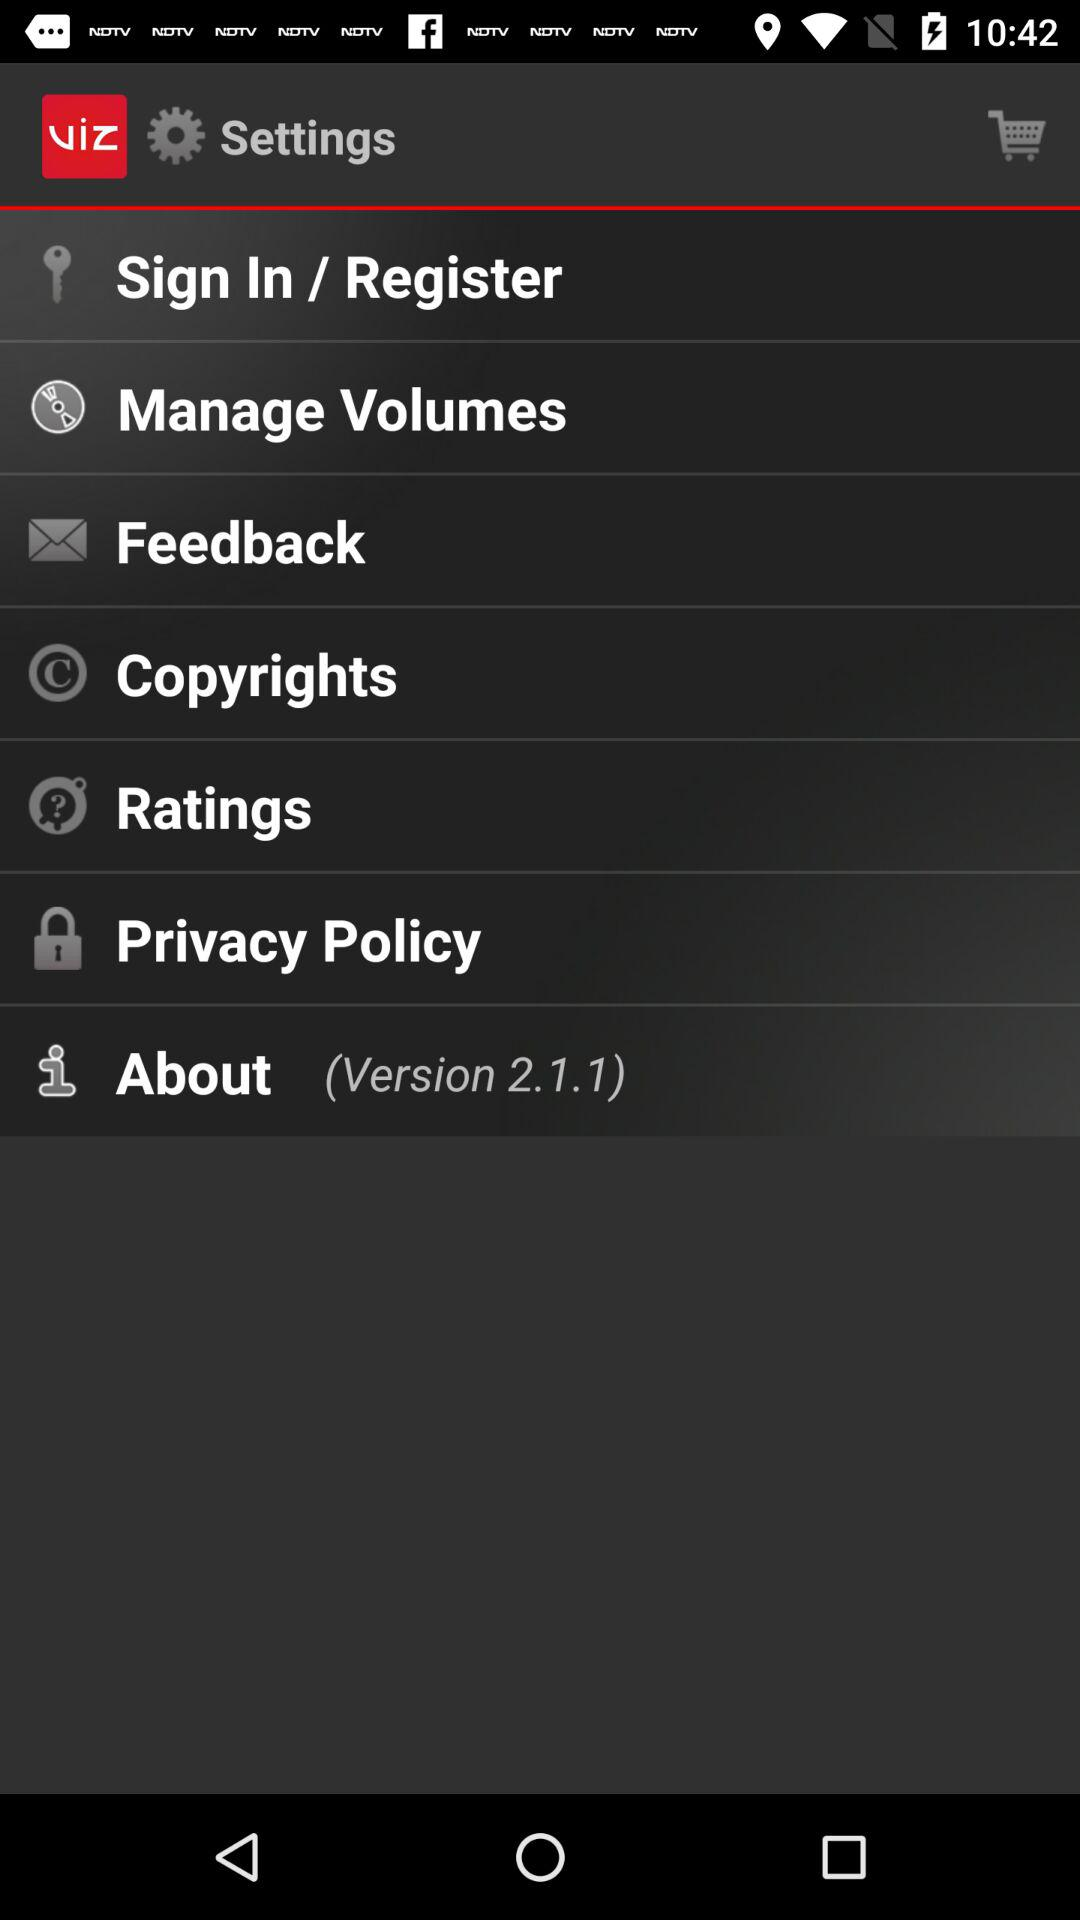What version of the application is this? The version is 2.1.1. 